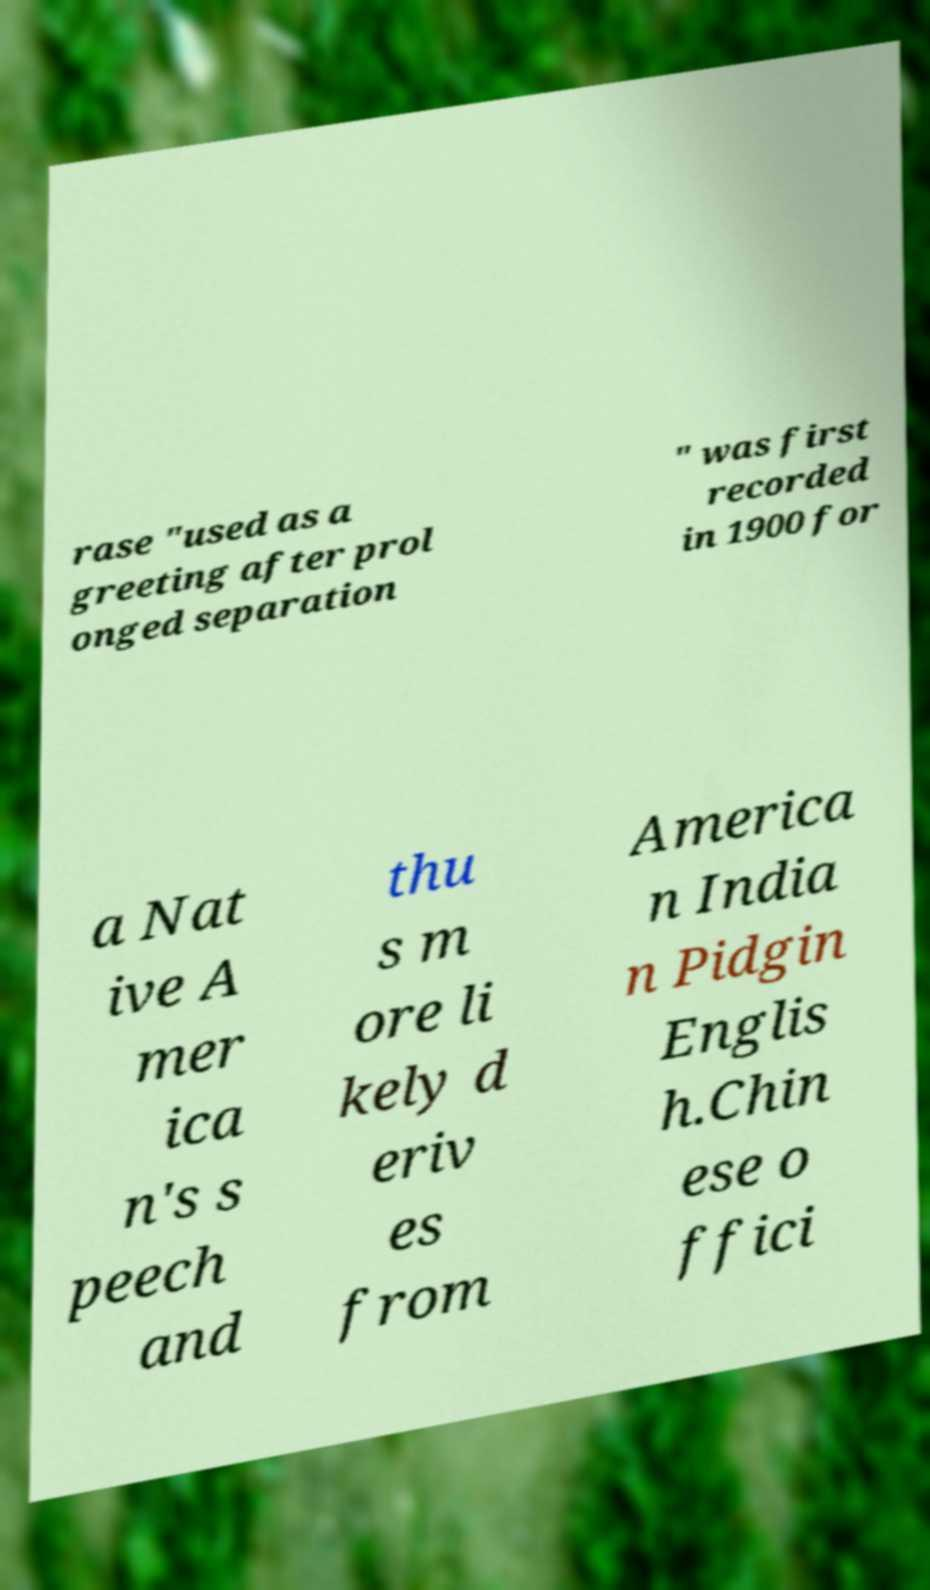Can you read and provide the text displayed in the image?This photo seems to have some interesting text. Can you extract and type it out for me? rase "used as a greeting after prol onged separation " was first recorded in 1900 for a Nat ive A mer ica n's s peech and thu s m ore li kely d eriv es from America n India n Pidgin Englis h.Chin ese o ffici 